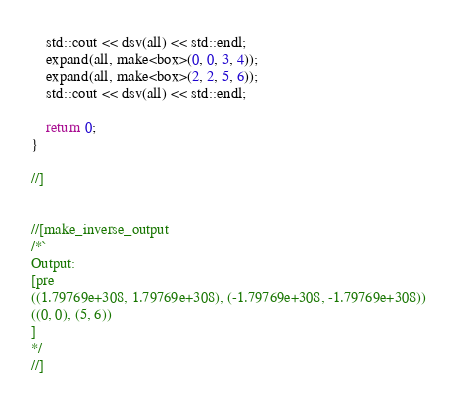<code> <loc_0><loc_0><loc_500><loc_500><_C++_>    std::cout << dsv(all) << std::endl;
    expand(all, make<box>(0, 0, 3, 4));
    expand(all, make<box>(2, 2, 5, 6));
    std::cout << dsv(all) << std::endl;

    return 0;
}

//]


//[make_inverse_output
/*`
Output:
[pre
((1.79769e+308, 1.79769e+308), (-1.79769e+308, -1.79769e+308))
((0, 0), (5, 6))
]
*/
//]
</code> 